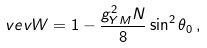<formula> <loc_0><loc_0><loc_500><loc_500>\ v e v { W } = 1 - \frac { g _ { Y M } ^ { 2 } N } { 8 } \sin ^ { 2 } \theta _ { 0 } \, ,</formula> 